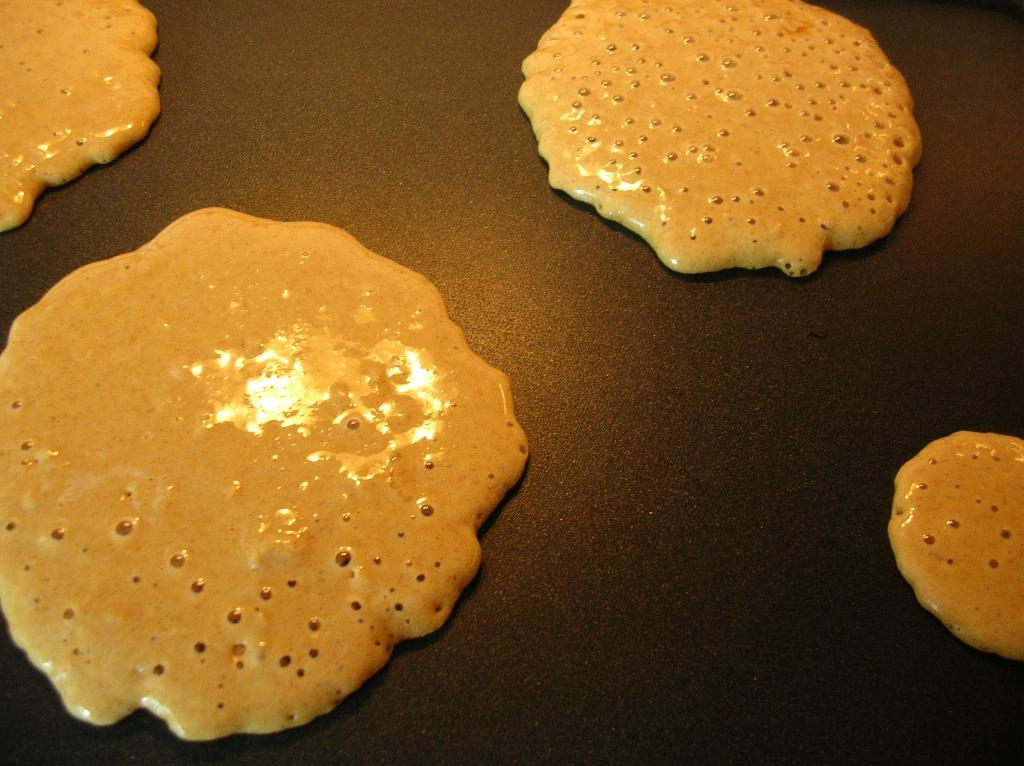What type of food can be seen in the image? There are pancakes in the image. What type of whip is used to make the pancakes in the image? There is no whip present in the image, and the process of making pancakes does not involve a whip. 